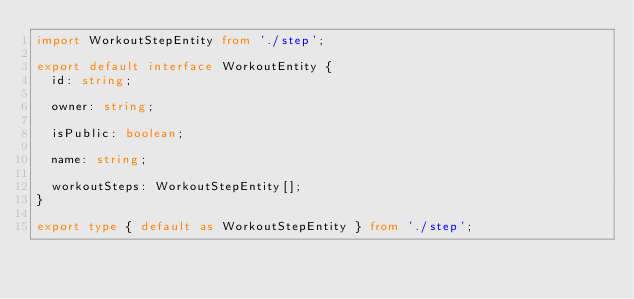<code> <loc_0><loc_0><loc_500><loc_500><_TypeScript_>import WorkoutStepEntity from './step';

export default interface WorkoutEntity {
  id: string;

  owner: string;

  isPublic: boolean;

  name: string;

  workoutSteps: WorkoutStepEntity[];
}

export type { default as WorkoutStepEntity } from './step';
</code> 